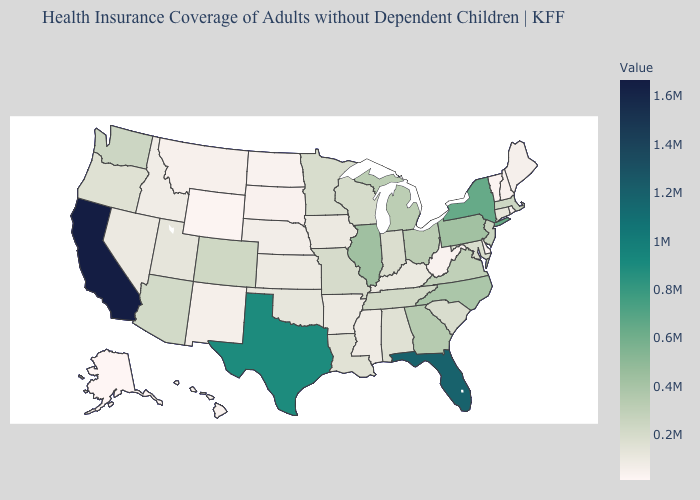Which states have the lowest value in the MidWest?
Give a very brief answer. North Dakota. Does Delaware have the lowest value in the South?
Concise answer only. Yes. Among the states that border Idaho , does Utah have the highest value?
Be succinct. No. Does Ohio have the highest value in the MidWest?
Concise answer only. No. Does Utah have the lowest value in the West?
Answer briefly. No. Which states have the lowest value in the Northeast?
Concise answer only. Vermont. Among the states that border Louisiana , which have the highest value?
Short answer required. Texas. 